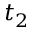Convert formula to latex. <formula><loc_0><loc_0><loc_500><loc_500>t _ { 2 }</formula> 